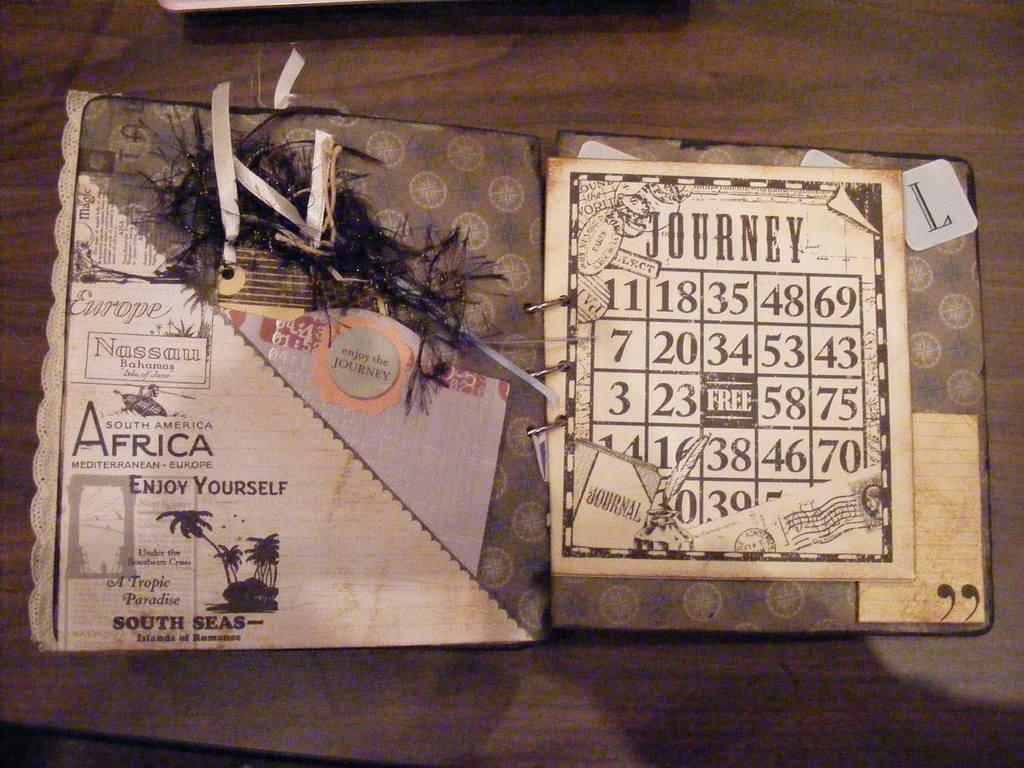<image>
Give a short and clear explanation of the subsequent image. A postcard from Africa with a Journey bingo card on the front. 